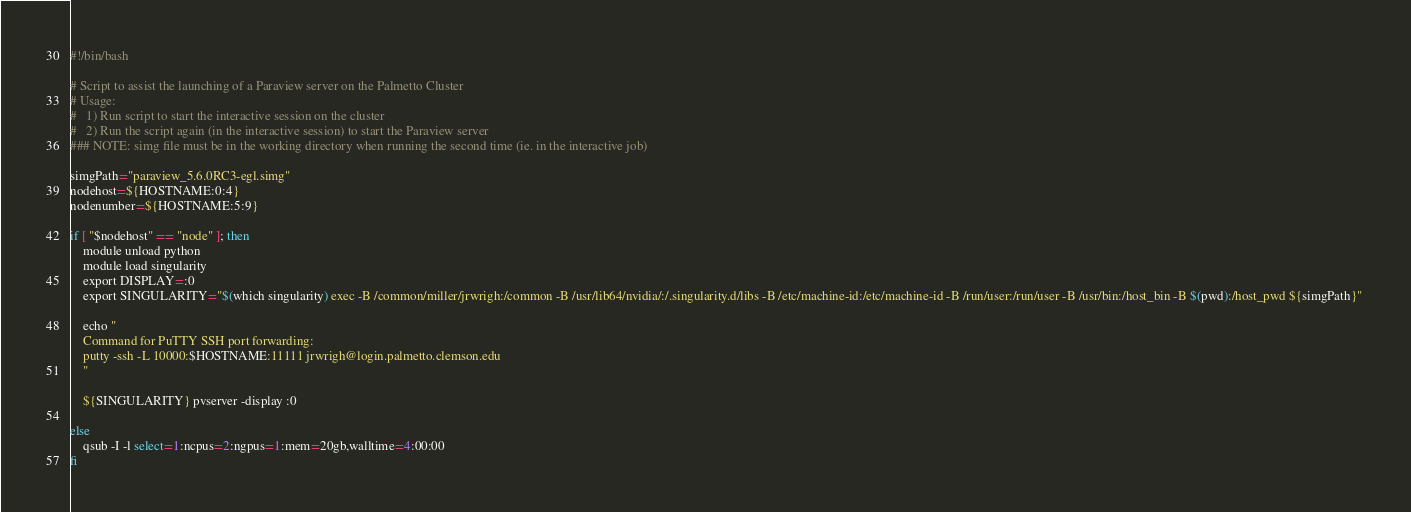Convert code to text. <code><loc_0><loc_0><loc_500><loc_500><_Bash_>#!/bin/bash

# Script to assist the launching of a Paraview server on the Palmetto Cluster
# Usage:
# 	1) Run script to start the interactive session on the cluster
#	2) Run the script again (in the interactive session) to start the Paraview server
### NOTE: simg file must be in the working directory when running the second time (ie. in the interactive job)

simgPath="paraview_5.6.0RC3-egl.simg"
nodehost=${HOSTNAME:0:4} 
nodenumber=${HOSTNAME:5:9}

if [ "$nodehost" == "node" ]; then
    module unload python
	module load singularity
	export DISPLAY=:0
	export SINGULARITY="$(which singularity) exec -B /common/miller/jrwrigh:/common -B /usr/lib64/nvidia/:/.singularity.d/libs -B /etc/machine-id:/etc/machine-id -B /run/user:/run/user -B /usr/bin:/host_bin -B $(pwd):/host_pwd ${simgPath}" 

    echo "
    Command for PuTTY SSH port forwarding:
    putty -ssh -L 10000:$HOSTNAME:11111 jrwrigh@login.palmetto.clemson.edu
    "

	${SINGULARITY} pvserver -display :0
 
else 
	qsub -I -l select=1:ncpus=2:ngpus=1:mem=20gb,walltime=4:00:00
fi 

</code> 